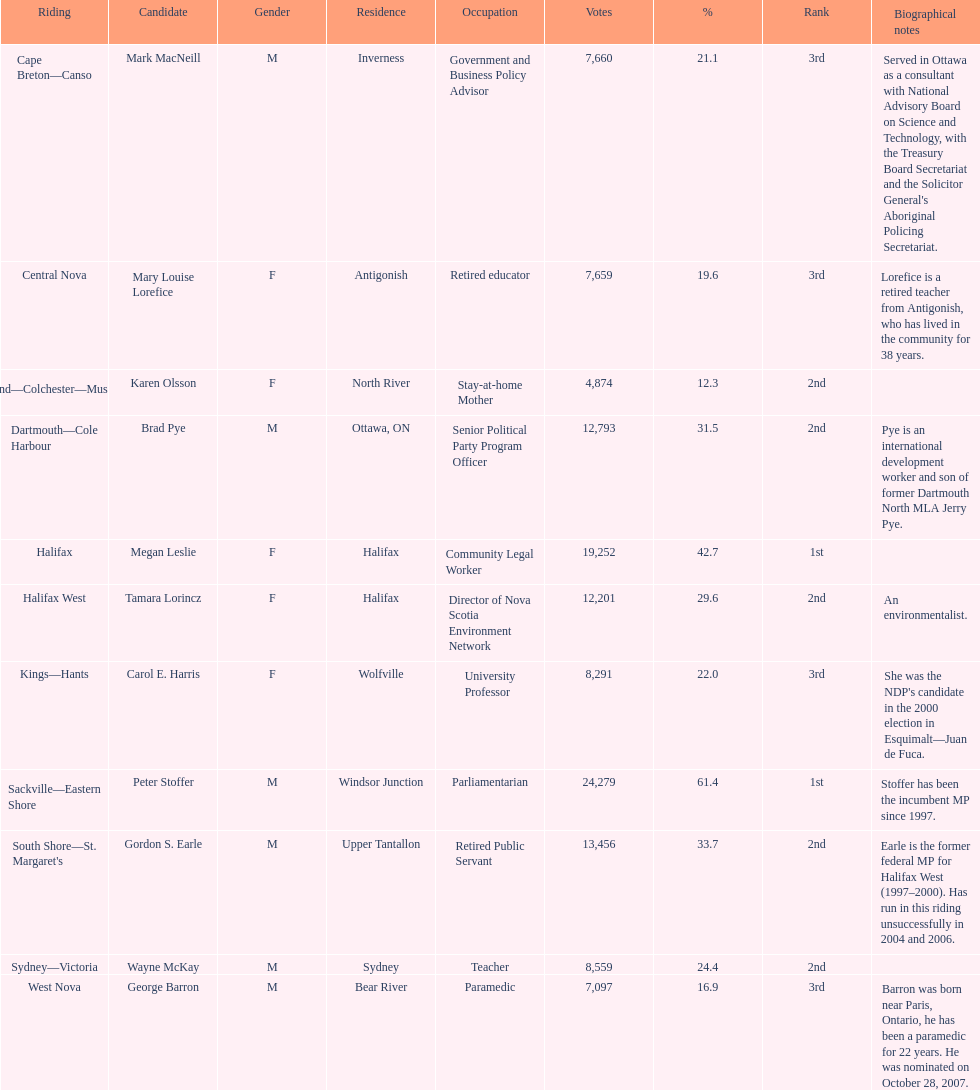Who received the highest number of votes? Sackville-Eastern Shore. 